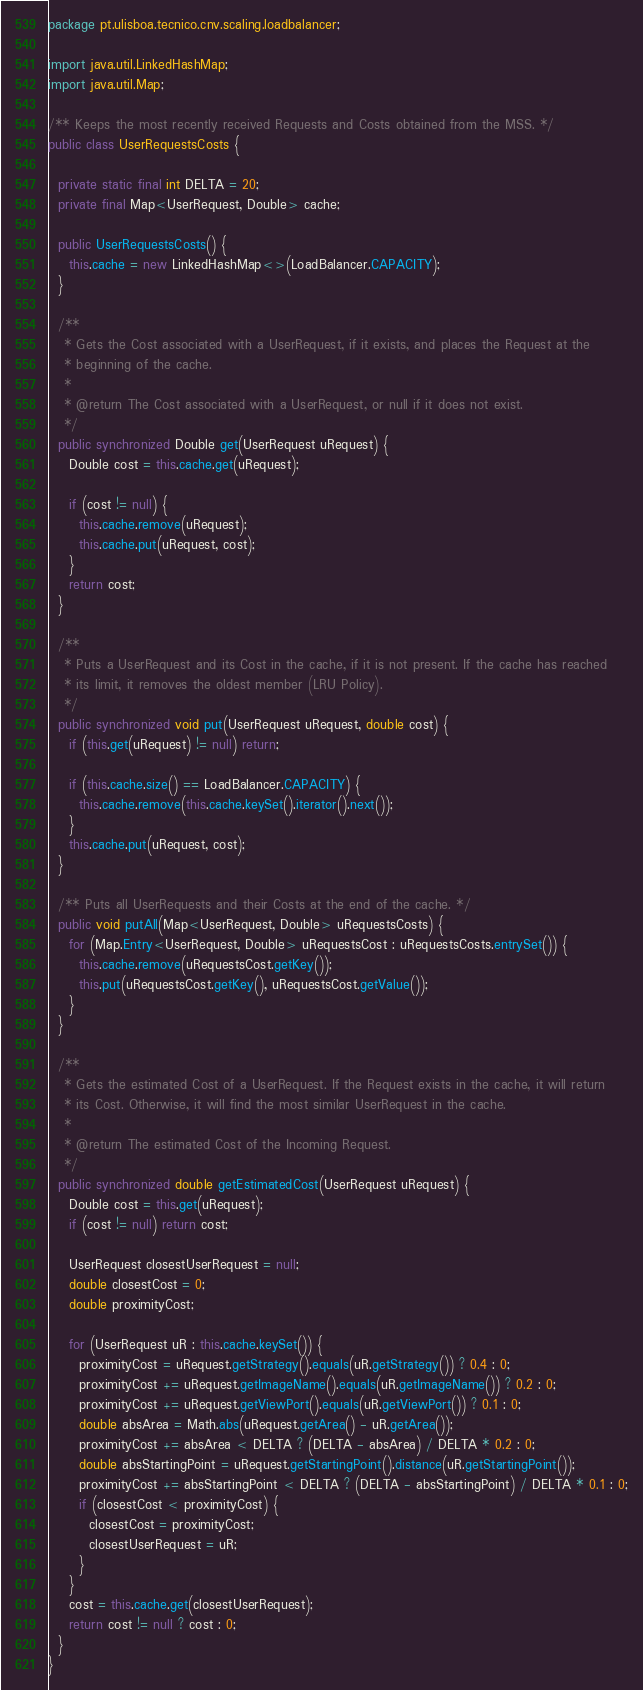Convert code to text. <code><loc_0><loc_0><loc_500><loc_500><_Java_>package pt.ulisboa.tecnico.cnv.scaling.loadbalancer;

import java.util.LinkedHashMap;
import java.util.Map;

/** Keeps the most recently received Requests and Costs obtained from the MSS. */
public class UserRequestsCosts {

  private static final int DELTA = 20;
  private final Map<UserRequest, Double> cache;

  public UserRequestsCosts() {
    this.cache = new LinkedHashMap<>(LoadBalancer.CAPACITY);
  }

  /**
   * Gets the Cost associated with a UserRequest, if it exists, and places the Request at the
   * beginning of the cache.
   *
   * @return The Cost associated with a UserRequest, or null if it does not exist.
   */
  public synchronized Double get(UserRequest uRequest) {
    Double cost = this.cache.get(uRequest);

    if (cost != null) {
      this.cache.remove(uRequest);
      this.cache.put(uRequest, cost);
    }
    return cost;
  }

  /**
   * Puts a UserRequest and its Cost in the cache, if it is not present. If the cache has reached
   * its limit, it removes the oldest member (LRU Policy).
   */
  public synchronized void put(UserRequest uRequest, double cost) {
    if (this.get(uRequest) != null) return;

    if (this.cache.size() == LoadBalancer.CAPACITY) {
      this.cache.remove(this.cache.keySet().iterator().next());
    }
    this.cache.put(uRequest, cost);
  }

  /** Puts all UserRequests and their Costs at the end of the cache. */
  public void putAll(Map<UserRequest, Double> uRequestsCosts) {
    for (Map.Entry<UserRequest, Double> uRequestsCost : uRequestsCosts.entrySet()) {
      this.cache.remove(uRequestsCost.getKey());
      this.put(uRequestsCost.getKey(), uRequestsCost.getValue());
    }
  }

  /**
   * Gets the estimated Cost of a UserRequest. If the Request exists in the cache, it will return
   * its Cost. Otherwise, it will find the most similar UserRequest in the cache.
   *
   * @return The estimated Cost of the Incoming Request.
   */
  public synchronized double getEstimatedCost(UserRequest uRequest) {
    Double cost = this.get(uRequest);
    if (cost != null) return cost;

    UserRequest closestUserRequest = null;
    double closestCost = 0;
    double proximityCost;

    for (UserRequest uR : this.cache.keySet()) {
      proximityCost = uRequest.getStrategy().equals(uR.getStrategy()) ? 0.4 : 0;
      proximityCost += uRequest.getImageName().equals(uR.getImageName()) ? 0.2 : 0;
      proximityCost += uRequest.getViewPort().equals(uR.getViewPort()) ? 0.1 : 0;
      double absArea = Math.abs(uRequest.getArea() - uR.getArea());
      proximityCost += absArea < DELTA ? (DELTA - absArea) / DELTA * 0.2 : 0;
      double absStartingPoint = uRequest.getStartingPoint().distance(uR.getStartingPoint());
      proximityCost += absStartingPoint < DELTA ? (DELTA - absStartingPoint) / DELTA * 0.1 : 0;
      if (closestCost < proximityCost) {
        closestCost = proximityCost;
        closestUserRequest = uR;
      }
    }
    cost = this.cache.get(closestUserRequest);
    return cost != null ? cost : 0;
  }
}
</code> 